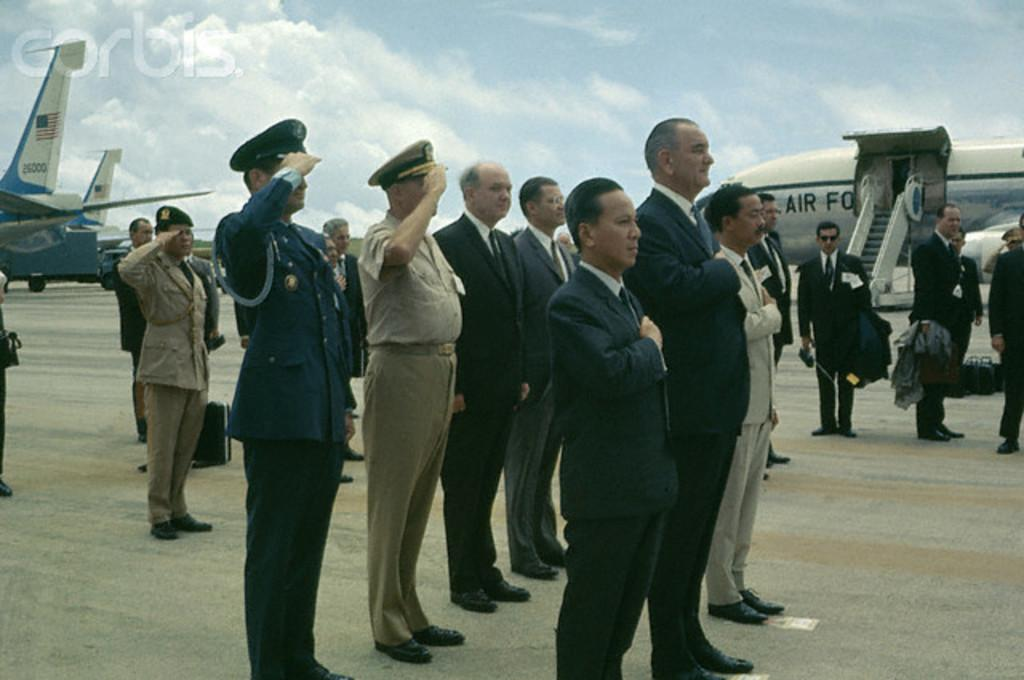How many people are in the image? There is a group of people in the image. Where are the people standing? The people are standing on a path. What else can be seen in the image besides the group of people? Airplanes are visible in the image. What is the condition of the sky in the image? The sky is cloudy in the image. What color is the sweater worn by the person holding the spade in the image? There is no person holding a spade in the image, nor is there a sweater mentioned. 